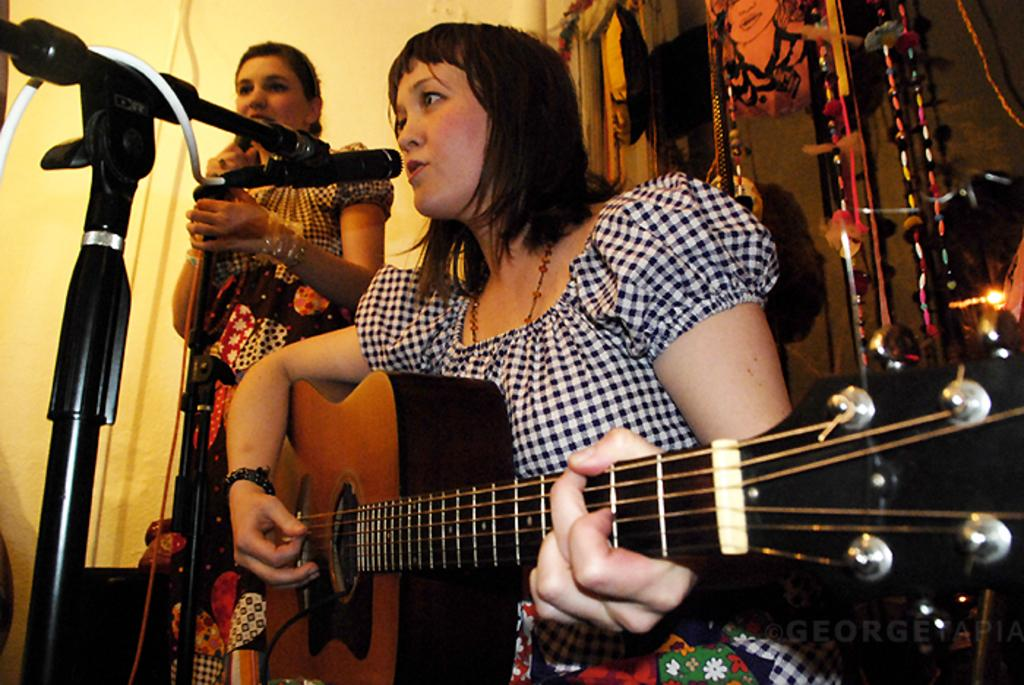What is the woman in the image doing? The woman is sitting and playing a guitar in the image. What is in front of the woman? The woman is in front of a mic. Are there any other people in the image? Yes, there is another woman standing in the image. What type of fuel is being used by the guitar in the image? There is no fuel involved in the guitar's operation, as it is a musical instrument played by the woman. 